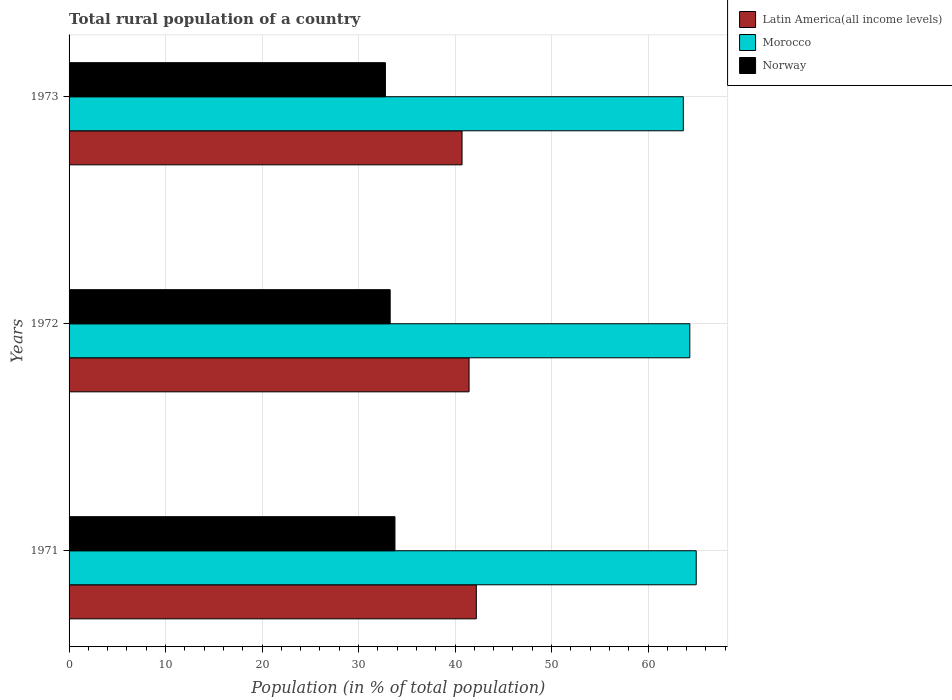How many different coloured bars are there?
Provide a short and direct response. 3. Are the number of bars on each tick of the Y-axis equal?
Your answer should be very brief. Yes. In how many cases, is the number of bars for a given year not equal to the number of legend labels?
Ensure brevity in your answer.  0. What is the rural population in Morocco in 1972?
Keep it short and to the point. 64.33. Across all years, what is the maximum rural population in Morocco?
Your answer should be very brief. 64.99. Across all years, what is the minimum rural population in Norway?
Your response must be concise. 32.78. What is the total rural population in Morocco in the graph?
Provide a succinct answer. 192.96. What is the difference between the rural population in Latin America(all income levels) in 1971 and that in 1973?
Provide a succinct answer. 1.48. What is the difference between the rural population in Latin America(all income levels) in 1971 and the rural population in Morocco in 1973?
Your answer should be very brief. -21.45. What is the average rural population in Morocco per year?
Keep it short and to the point. 64.32. In the year 1971, what is the difference between the rural population in Morocco and rural population in Latin America(all income levels)?
Offer a terse response. 22.79. In how many years, is the rural population in Morocco greater than 34 %?
Offer a terse response. 3. What is the ratio of the rural population in Morocco in 1971 to that in 1973?
Make the answer very short. 1.02. Is the rural population in Morocco in 1971 less than that in 1972?
Your answer should be compact. No. Is the difference between the rural population in Morocco in 1972 and 1973 greater than the difference between the rural population in Latin America(all income levels) in 1972 and 1973?
Keep it short and to the point. No. What is the difference between the highest and the second highest rural population in Morocco?
Give a very brief answer. 0.66. What is the difference between the highest and the lowest rural population in Latin America(all income levels)?
Give a very brief answer. 1.48. In how many years, is the rural population in Morocco greater than the average rural population in Morocco taken over all years?
Provide a short and direct response. 2. What does the 3rd bar from the top in 1971 represents?
Your answer should be very brief. Latin America(all income levels). What does the 1st bar from the bottom in 1972 represents?
Offer a terse response. Latin America(all income levels). How many years are there in the graph?
Your answer should be very brief. 3. Are the values on the major ticks of X-axis written in scientific E-notation?
Your answer should be compact. No. Does the graph contain grids?
Your answer should be very brief. Yes. How many legend labels are there?
Keep it short and to the point. 3. What is the title of the graph?
Your answer should be very brief. Total rural population of a country. What is the label or title of the X-axis?
Ensure brevity in your answer.  Population (in % of total population). What is the Population (in % of total population) in Latin America(all income levels) in 1971?
Give a very brief answer. 42.2. What is the Population (in % of total population) of Morocco in 1971?
Keep it short and to the point. 64.99. What is the Population (in % of total population) of Norway in 1971?
Offer a terse response. 33.77. What is the Population (in % of total population) of Latin America(all income levels) in 1972?
Make the answer very short. 41.45. What is the Population (in % of total population) of Morocco in 1972?
Your answer should be very brief. 64.33. What is the Population (in % of total population) of Norway in 1972?
Your answer should be very brief. 33.27. What is the Population (in % of total population) of Latin America(all income levels) in 1973?
Make the answer very short. 40.72. What is the Population (in % of total population) of Morocco in 1973?
Your answer should be very brief. 63.65. What is the Population (in % of total population) of Norway in 1973?
Provide a succinct answer. 32.78. Across all years, what is the maximum Population (in % of total population) of Latin America(all income levels)?
Your answer should be very brief. 42.2. Across all years, what is the maximum Population (in % of total population) of Morocco?
Your answer should be compact. 64.99. Across all years, what is the maximum Population (in % of total population) in Norway?
Offer a very short reply. 33.77. Across all years, what is the minimum Population (in % of total population) of Latin America(all income levels)?
Make the answer very short. 40.72. Across all years, what is the minimum Population (in % of total population) of Morocco?
Give a very brief answer. 63.65. Across all years, what is the minimum Population (in % of total population) of Norway?
Provide a succinct answer. 32.78. What is the total Population (in % of total population) of Latin America(all income levels) in the graph?
Offer a terse response. 124.37. What is the total Population (in % of total population) in Morocco in the graph?
Provide a short and direct response. 192.96. What is the total Population (in % of total population) in Norway in the graph?
Ensure brevity in your answer.  99.83. What is the difference between the Population (in % of total population) in Latin America(all income levels) in 1971 and that in 1972?
Offer a very short reply. 0.75. What is the difference between the Population (in % of total population) of Morocco in 1971 and that in 1972?
Provide a short and direct response. 0.66. What is the difference between the Population (in % of total population) in Norway in 1971 and that in 1972?
Your answer should be very brief. 0.49. What is the difference between the Population (in % of total population) of Latin America(all income levels) in 1971 and that in 1973?
Ensure brevity in your answer.  1.48. What is the difference between the Population (in % of total population) in Morocco in 1971 and that in 1973?
Your response must be concise. 1.34. What is the difference between the Population (in % of total population) of Norway in 1971 and that in 1973?
Keep it short and to the point. 0.99. What is the difference between the Population (in % of total population) in Latin America(all income levels) in 1972 and that in 1973?
Keep it short and to the point. 0.73. What is the difference between the Population (in % of total population) in Morocco in 1972 and that in 1973?
Your response must be concise. 0.67. What is the difference between the Population (in % of total population) in Norway in 1972 and that in 1973?
Your answer should be compact. 0.49. What is the difference between the Population (in % of total population) of Latin America(all income levels) in 1971 and the Population (in % of total population) of Morocco in 1972?
Offer a terse response. -22.12. What is the difference between the Population (in % of total population) of Latin America(all income levels) in 1971 and the Population (in % of total population) of Norway in 1972?
Keep it short and to the point. 8.93. What is the difference between the Population (in % of total population) in Morocco in 1971 and the Population (in % of total population) in Norway in 1972?
Provide a succinct answer. 31.71. What is the difference between the Population (in % of total population) of Latin America(all income levels) in 1971 and the Population (in % of total population) of Morocco in 1973?
Ensure brevity in your answer.  -21.45. What is the difference between the Population (in % of total population) in Latin America(all income levels) in 1971 and the Population (in % of total population) in Norway in 1973?
Make the answer very short. 9.42. What is the difference between the Population (in % of total population) in Morocco in 1971 and the Population (in % of total population) in Norway in 1973?
Your response must be concise. 32.2. What is the difference between the Population (in % of total population) of Latin America(all income levels) in 1972 and the Population (in % of total population) of Morocco in 1973?
Your answer should be very brief. -22.2. What is the difference between the Population (in % of total population) in Latin America(all income levels) in 1972 and the Population (in % of total population) in Norway in 1973?
Provide a succinct answer. 8.67. What is the difference between the Population (in % of total population) of Morocco in 1972 and the Population (in % of total population) of Norway in 1973?
Make the answer very short. 31.54. What is the average Population (in % of total population) of Latin America(all income levels) per year?
Provide a succinct answer. 41.46. What is the average Population (in % of total population) in Morocco per year?
Your answer should be compact. 64.32. What is the average Population (in % of total population) in Norway per year?
Your answer should be very brief. 33.28. In the year 1971, what is the difference between the Population (in % of total population) in Latin America(all income levels) and Population (in % of total population) in Morocco?
Offer a very short reply. -22.79. In the year 1971, what is the difference between the Population (in % of total population) of Latin America(all income levels) and Population (in % of total population) of Norway?
Make the answer very short. 8.43. In the year 1971, what is the difference between the Population (in % of total population) of Morocco and Population (in % of total population) of Norway?
Provide a succinct answer. 31.22. In the year 1972, what is the difference between the Population (in % of total population) of Latin America(all income levels) and Population (in % of total population) of Morocco?
Ensure brevity in your answer.  -22.88. In the year 1972, what is the difference between the Population (in % of total population) of Latin America(all income levels) and Population (in % of total population) of Norway?
Your answer should be compact. 8.17. In the year 1972, what is the difference between the Population (in % of total population) of Morocco and Population (in % of total population) of Norway?
Make the answer very short. 31.05. In the year 1973, what is the difference between the Population (in % of total population) in Latin America(all income levels) and Population (in % of total population) in Morocco?
Give a very brief answer. -22.93. In the year 1973, what is the difference between the Population (in % of total population) in Latin America(all income levels) and Population (in % of total population) in Norway?
Keep it short and to the point. 7.94. In the year 1973, what is the difference between the Population (in % of total population) of Morocco and Population (in % of total population) of Norway?
Ensure brevity in your answer.  30.87. What is the ratio of the Population (in % of total population) of Latin America(all income levels) in 1971 to that in 1972?
Provide a succinct answer. 1.02. What is the ratio of the Population (in % of total population) of Morocco in 1971 to that in 1972?
Make the answer very short. 1.01. What is the ratio of the Population (in % of total population) in Norway in 1971 to that in 1972?
Your answer should be compact. 1.01. What is the ratio of the Population (in % of total population) in Latin America(all income levels) in 1971 to that in 1973?
Make the answer very short. 1.04. What is the ratio of the Population (in % of total population) of Morocco in 1971 to that in 1973?
Your answer should be compact. 1.02. What is the ratio of the Population (in % of total population) in Norway in 1971 to that in 1973?
Your answer should be very brief. 1.03. What is the ratio of the Population (in % of total population) of Latin America(all income levels) in 1972 to that in 1973?
Make the answer very short. 1.02. What is the ratio of the Population (in % of total population) in Morocco in 1972 to that in 1973?
Offer a very short reply. 1.01. What is the ratio of the Population (in % of total population) of Norway in 1972 to that in 1973?
Keep it short and to the point. 1.01. What is the difference between the highest and the second highest Population (in % of total population) in Latin America(all income levels)?
Your answer should be very brief. 0.75. What is the difference between the highest and the second highest Population (in % of total population) in Morocco?
Make the answer very short. 0.66. What is the difference between the highest and the second highest Population (in % of total population) of Norway?
Your answer should be very brief. 0.49. What is the difference between the highest and the lowest Population (in % of total population) in Latin America(all income levels)?
Provide a short and direct response. 1.48. What is the difference between the highest and the lowest Population (in % of total population) of Morocco?
Keep it short and to the point. 1.34. 